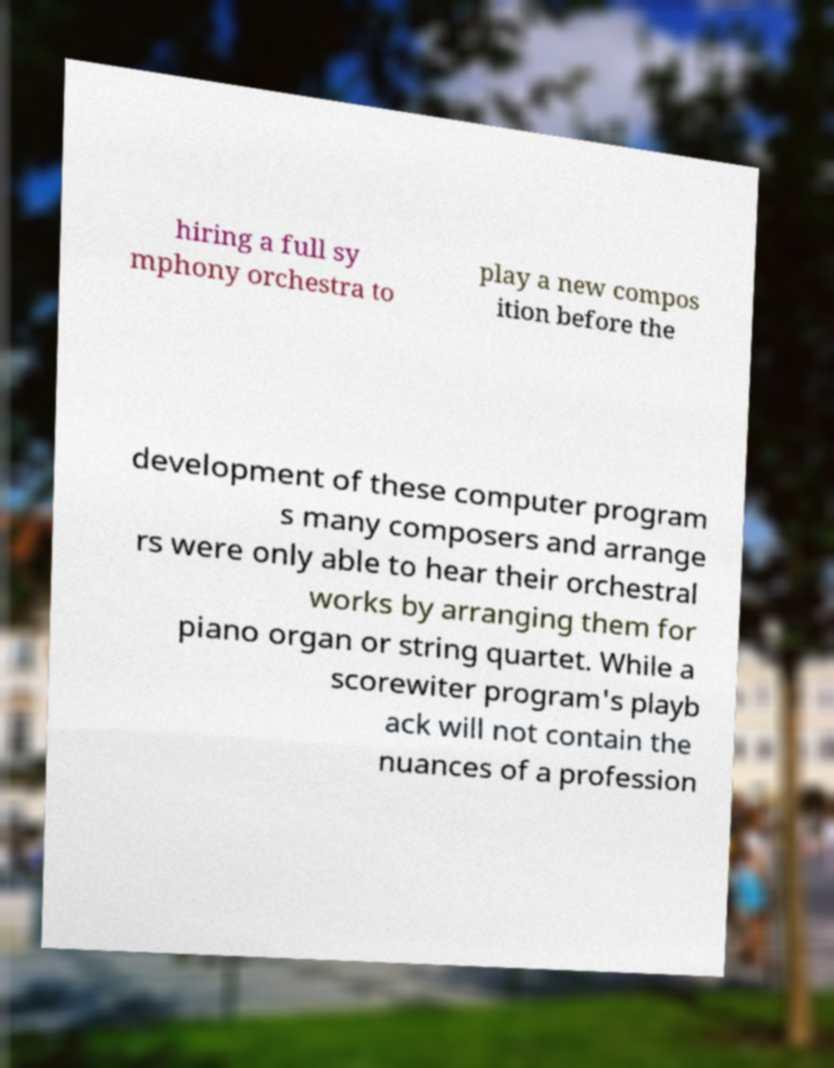I need the written content from this picture converted into text. Can you do that? hiring a full sy mphony orchestra to play a new compos ition before the development of these computer program s many composers and arrange rs were only able to hear their orchestral works by arranging them for piano organ or string quartet. While a scorewiter program's playb ack will not contain the nuances of a profession 